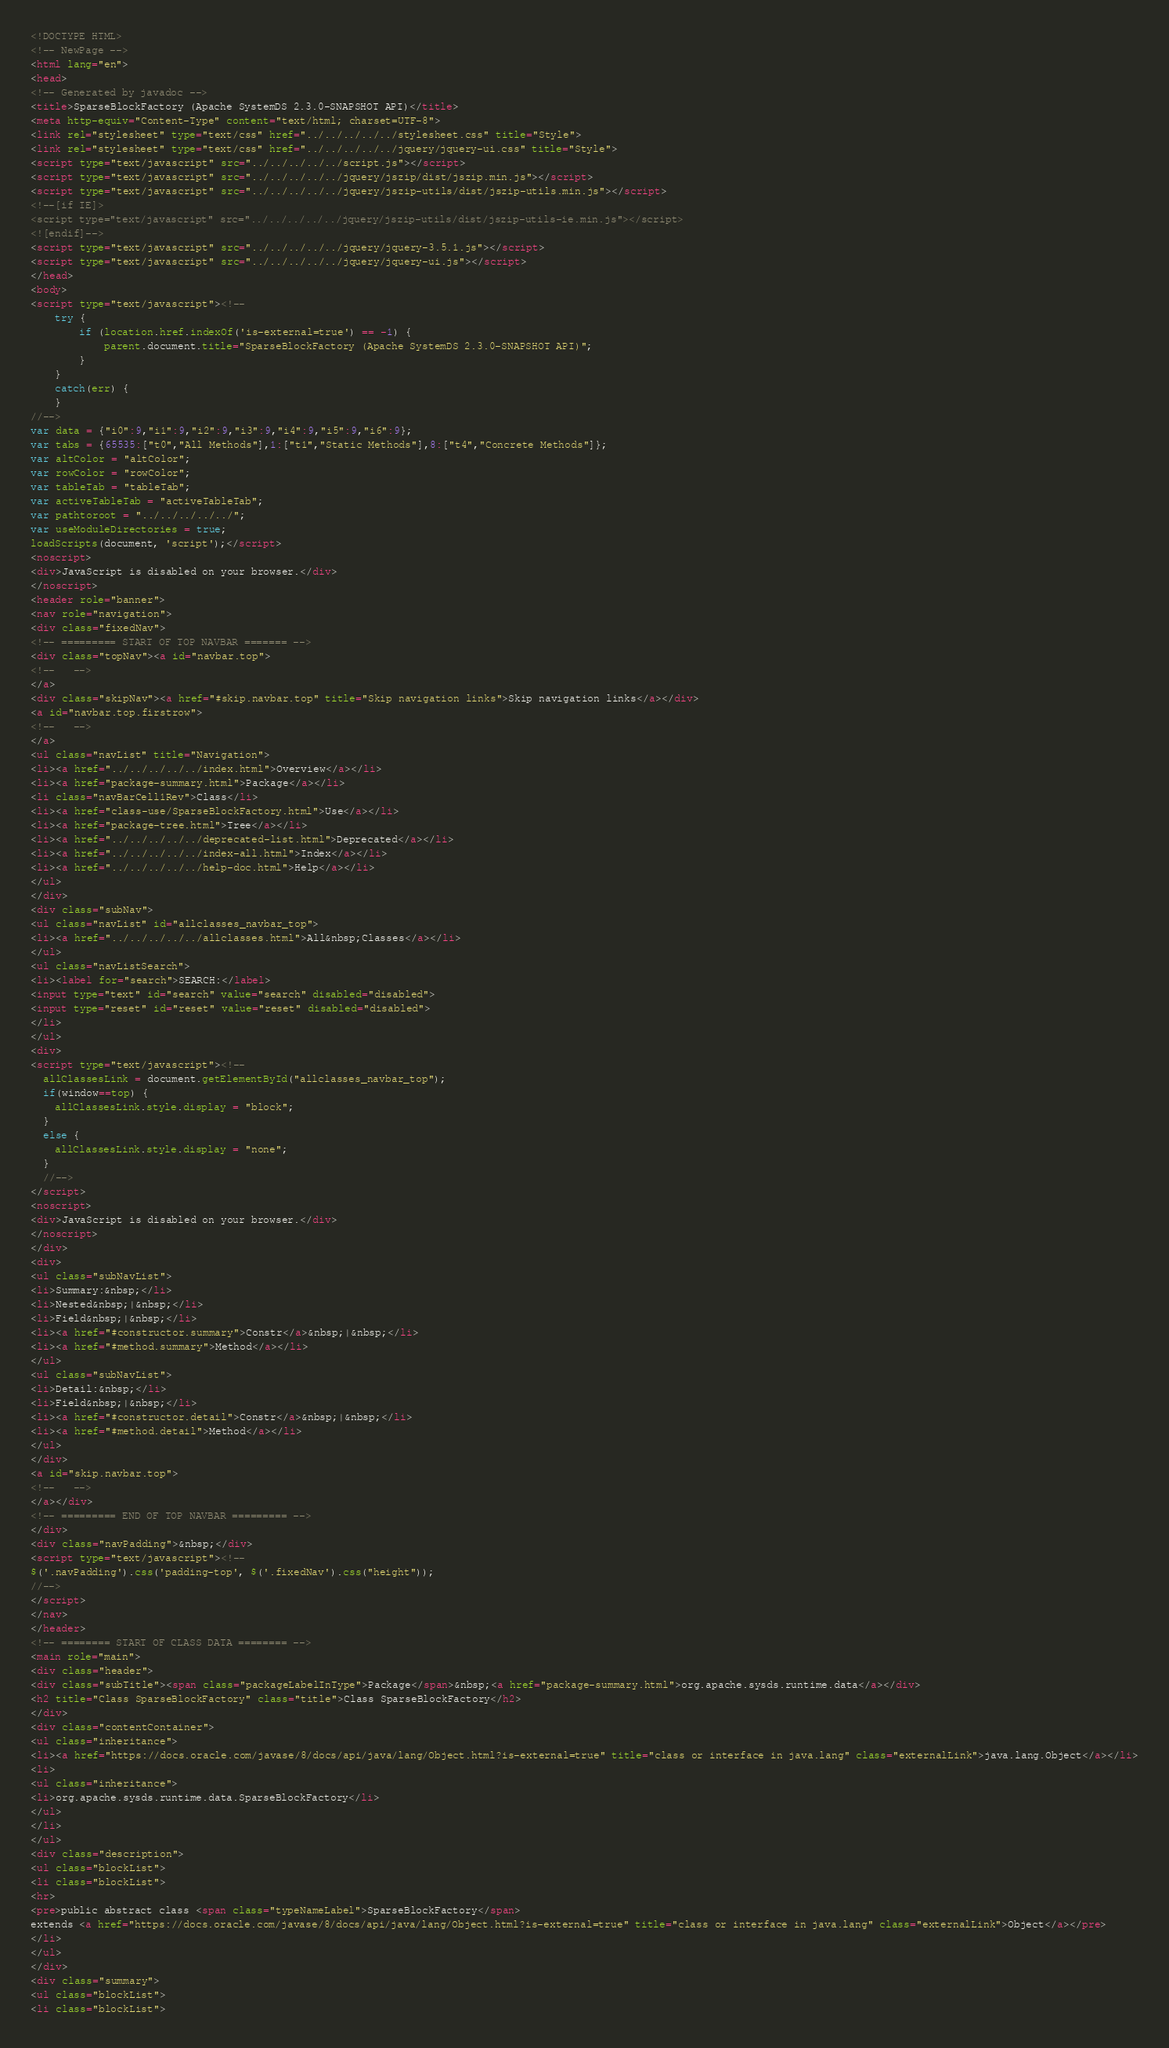<code> <loc_0><loc_0><loc_500><loc_500><_HTML_><!DOCTYPE HTML>
<!-- NewPage -->
<html lang="en">
<head>
<!-- Generated by javadoc -->
<title>SparseBlockFactory (Apache SystemDS 2.3.0-SNAPSHOT API)</title>
<meta http-equiv="Content-Type" content="text/html; charset=UTF-8">
<link rel="stylesheet" type="text/css" href="../../../../../stylesheet.css" title="Style">
<link rel="stylesheet" type="text/css" href="../../../../../jquery/jquery-ui.css" title="Style">
<script type="text/javascript" src="../../../../../script.js"></script>
<script type="text/javascript" src="../../../../../jquery/jszip/dist/jszip.min.js"></script>
<script type="text/javascript" src="../../../../../jquery/jszip-utils/dist/jszip-utils.min.js"></script>
<!--[if IE]>
<script type="text/javascript" src="../../../../../jquery/jszip-utils/dist/jszip-utils-ie.min.js"></script>
<![endif]-->
<script type="text/javascript" src="../../../../../jquery/jquery-3.5.1.js"></script>
<script type="text/javascript" src="../../../../../jquery/jquery-ui.js"></script>
</head>
<body>
<script type="text/javascript"><!--
    try {
        if (location.href.indexOf('is-external=true') == -1) {
            parent.document.title="SparseBlockFactory (Apache SystemDS 2.3.0-SNAPSHOT API)";
        }
    }
    catch(err) {
    }
//-->
var data = {"i0":9,"i1":9,"i2":9,"i3":9,"i4":9,"i5":9,"i6":9};
var tabs = {65535:["t0","All Methods"],1:["t1","Static Methods"],8:["t4","Concrete Methods"]};
var altColor = "altColor";
var rowColor = "rowColor";
var tableTab = "tableTab";
var activeTableTab = "activeTableTab";
var pathtoroot = "../../../../../";
var useModuleDirectories = true;
loadScripts(document, 'script');</script>
<noscript>
<div>JavaScript is disabled on your browser.</div>
</noscript>
<header role="banner">
<nav role="navigation">
<div class="fixedNav">
<!-- ========= START OF TOP NAVBAR ======= -->
<div class="topNav"><a id="navbar.top">
<!--   -->
</a>
<div class="skipNav"><a href="#skip.navbar.top" title="Skip navigation links">Skip navigation links</a></div>
<a id="navbar.top.firstrow">
<!--   -->
</a>
<ul class="navList" title="Navigation">
<li><a href="../../../../../index.html">Overview</a></li>
<li><a href="package-summary.html">Package</a></li>
<li class="navBarCell1Rev">Class</li>
<li><a href="class-use/SparseBlockFactory.html">Use</a></li>
<li><a href="package-tree.html">Tree</a></li>
<li><a href="../../../../../deprecated-list.html">Deprecated</a></li>
<li><a href="../../../../../index-all.html">Index</a></li>
<li><a href="../../../../../help-doc.html">Help</a></li>
</ul>
</div>
<div class="subNav">
<ul class="navList" id="allclasses_navbar_top">
<li><a href="../../../../../allclasses.html">All&nbsp;Classes</a></li>
</ul>
<ul class="navListSearch">
<li><label for="search">SEARCH:</label>
<input type="text" id="search" value="search" disabled="disabled">
<input type="reset" id="reset" value="reset" disabled="disabled">
</li>
</ul>
<div>
<script type="text/javascript"><!--
  allClassesLink = document.getElementById("allclasses_navbar_top");
  if(window==top) {
    allClassesLink.style.display = "block";
  }
  else {
    allClassesLink.style.display = "none";
  }
  //-->
</script>
<noscript>
<div>JavaScript is disabled on your browser.</div>
</noscript>
</div>
<div>
<ul class="subNavList">
<li>Summary:&nbsp;</li>
<li>Nested&nbsp;|&nbsp;</li>
<li>Field&nbsp;|&nbsp;</li>
<li><a href="#constructor.summary">Constr</a>&nbsp;|&nbsp;</li>
<li><a href="#method.summary">Method</a></li>
</ul>
<ul class="subNavList">
<li>Detail:&nbsp;</li>
<li>Field&nbsp;|&nbsp;</li>
<li><a href="#constructor.detail">Constr</a>&nbsp;|&nbsp;</li>
<li><a href="#method.detail">Method</a></li>
</ul>
</div>
<a id="skip.navbar.top">
<!--   -->
</a></div>
<!-- ========= END OF TOP NAVBAR ========= -->
</div>
<div class="navPadding">&nbsp;</div>
<script type="text/javascript"><!--
$('.navPadding').css('padding-top', $('.fixedNav').css("height"));
//-->
</script>
</nav>
</header>
<!-- ======== START OF CLASS DATA ======== -->
<main role="main">
<div class="header">
<div class="subTitle"><span class="packageLabelInType">Package</span>&nbsp;<a href="package-summary.html">org.apache.sysds.runtime.data</a></div>
<h2 title="Class SparseBlockFactory" class="title">Class SparseBlockFactory</h2>
</div>
<div class="contentContainer">
<ul class="inheritance">
<li><a href="https://docs.oracle.com/javase/8/docs/api/java/lang/Object.html?is-external=true" title="class or interface in java.lang" class="externalLink">java.lang.Object</a></li>
<li>
<ul class="inheritance">
<li>org.apache.sysds.runtime.data.SparseBlockFactory</li>
</ul>
</li>
</ul>
<div class="description">
<ul class="blockList">
<li class="blockList">
<hr>
<pre>public abstract class <span class="typeNameLabel">SparseBlockFactory</span>
extends <a href="https://docs.oracle.com/javase/8/docs/api/java/lang/Object.html?is-external=true" title="class or interface in java.lang" class="externalLink">Object</a></pre>
</li>
</ul>
</div>
<div class="summary">
<ul class="blockList">
<li class="blockList"></code> 